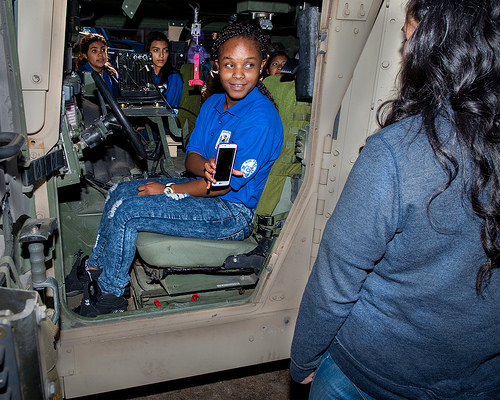<image>
Is there a phone in front of the truck? No. The phone is not in front of the truck. The spatial positioning shows a different relationship between these objects. 